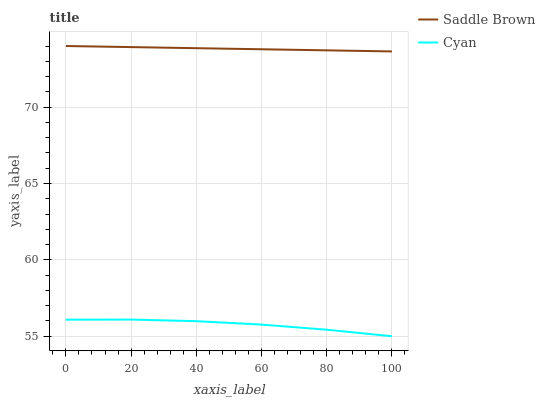Does Cyan have the minimum area under the curve?
Answer yes or no. Yes. Does Saddle Brown have the maximum area under the curve?
Answer yes or no. Yes. Does Saddle Brown have the minimum area under the curve?
Answer yes or no. No. Is Saddle Brown the smoothest?
Answer yes or no. Yes. Is Cyan the roughest?
Answer yes or no. Yes. Is Saddle Brown the roughest?
Answer yes or no. No. Does Saddle Brown have the lowest value?
Answer yes or no. No. Is Cyan less than Saddle Brown?
Answer yes or no. Yes. Is Saddle Brown greater than Cyan?
Answer yes or no. Yes. Does Cyan intersect Saddle Brown?
Answer yes or no. No. 